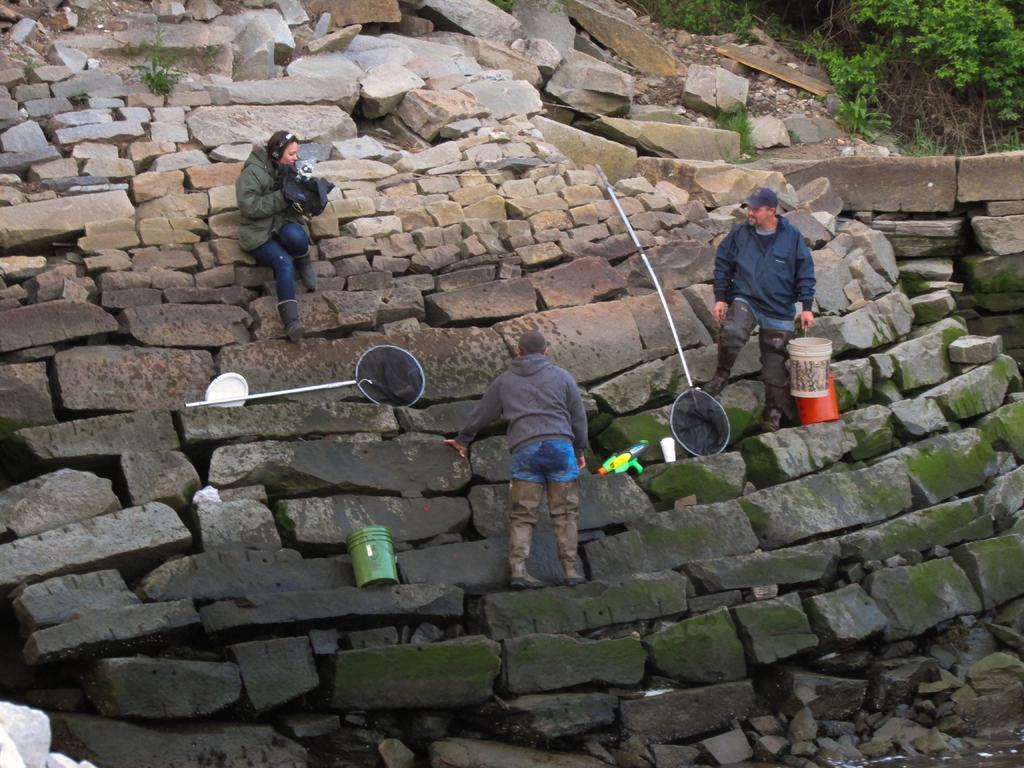Can you describe this image briefly? In this picture I can see few people standing and a man holding a bucket in his hand. I can see couple of buckets, a cup and couple of nets on the rocks and I can see a woman holding a cloth in her hands. I can see plants at the top right corner and water at the bottom right corner of the picture. 